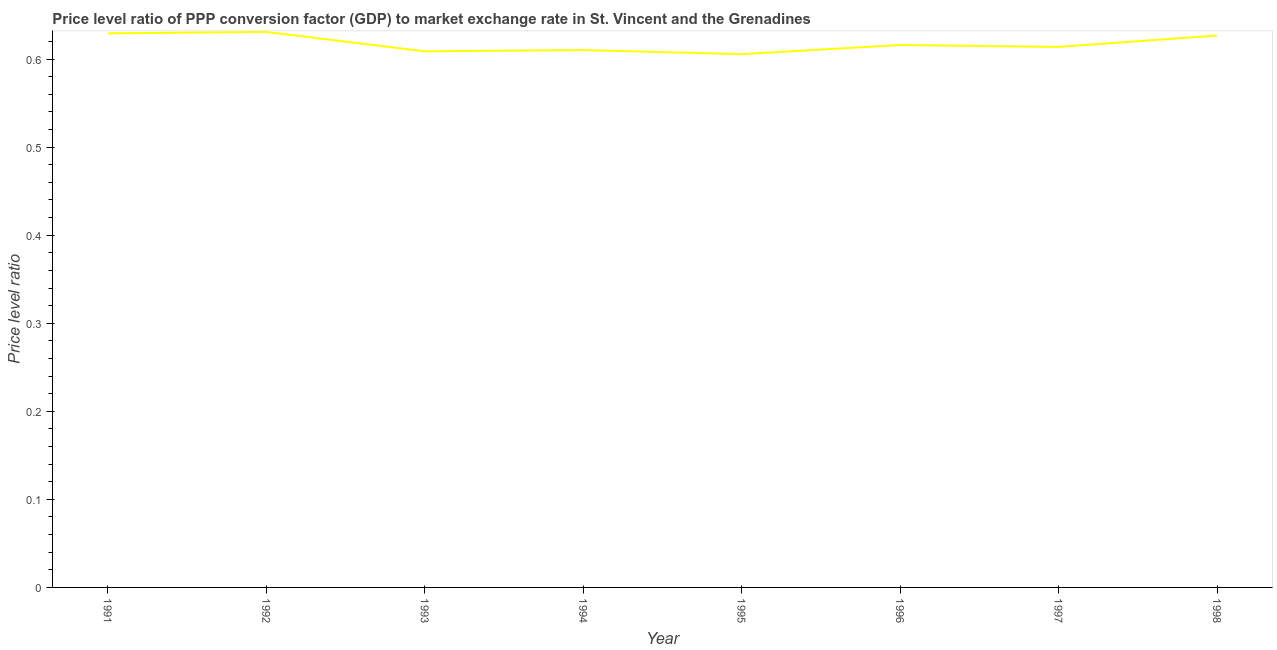What is the price level ratio in 1994?
Offer a very short reply. 0.61. Across all years, what is the maximum price level ratio?
Offer a very short reply. 0.63. Across all years, what is the minimum price level ratio?
Offer a terse response. 0.61. In which year was the price level ratio maximum?
Provide a succinct answer. 1992. In which year was the price level ratio minimum?
Your answer should be compact. 1995. What is the sum of the price level ratio?
Your response must be concise. 4.94. What is the difference between the price level ratio in 1994 and 1998?
Offer a very short reply. -0.02. What is the average price level ratio per year?
Ensure brevity in your answer.  0.62. What is the median price level ratio?
Ensure brevity in your answer.  0.61. In how many years, is the price level ratio greater than 0.22 ?
Make the answer very short. 8. Do a majority of the years between 1997 and 1992 (inclusive) have price level ratio greater than 0.30000000000000004 ?
Provide a succinct answer. Yes. What is the ratio of the price level ratio in 1993 to that in 1998?
Your response must be concise. 0.97. What is the difference between the highest and the second highest price level ratio?
Keep it short and to the point. 0. Is the sum of the price level ratio in 1995 and 1996 greater than the maximum price level ratio across all years?
Your answer should be very brief. Yes. What is the difference between the highest and the lowest price level ratio?
Ensure brevity in your answer.  0.03. In how many years, is the price level ratio greater than the average price level ratio taken over all years?
Your answer should be compact. 3. How many years are there in the graph?
Make the answer very short. 8. What is the difference between two consecutive major ticks on the Y-axis?
Give a very brief answer. 0.1. Does the graph contain any zero values?
Ensure brevity in your answer.  No. Does the graph contain grids?
Provide a short and direct response. No. What is the title of the graph?
Keep it short and to the point. Price level ratio of PPP conversion factor (GDP) to market exchange rate in St. Vincent and the Grenadines. What is the label or title of the Y-axis?
Ensure brevity in your answer.  Price level ratio. What is the Price level ratio in 1991?
Provide a short and direct response. 0.63. What is the Price level ratio of 1992?
Provide a succinct answer. 0.63. What is the Price level ratio of 1993?
Your answer should be compact. 0.61. What is the Price level ratio in 1994?
Keep it short and to the point. 0.61. What is the Price level ratio in 1995?
Your response must be concise. 0.61. What is the Price level ratio in 1996?
Offer a terse response. 0.62. What is the Price level ratio of 1997?
Offer a very short reply. 0.61. What is the Price level ratio in 1998?
Provide a succinct answer. 0.63. What is the difference between the Price level ratio in 1991 and 1992?
Keep it short and to the point. -0. What is the difference between the Price level ratio in 1991 and 1993?
Your response must be concise. 0.02. What is the difference between the Price level ratio in 1991 and 1994?
Give a very brief answer. 0.02. What is the difference between the Price level ratio in 1991 and 1995?
Make the answer very short. 0.02. What is the difference between the Price level ratio in 1991 and 1996?
Keep it short and to the point. 0.01. What is the difference between the Price level ratio in 1991 and 1997?
Make the answer very short. 0.02. What is the difference between the Price level ratio in 1991 and 1998?
Keep it short and to the point. 0. What is the difference between the Price level ratio in 1992 and 1993?
Your answer should be compact. 0.02. What is the difference between the Price level ratio in 1992 and 1994?
Give a very brief answer. 0.02. What is the difference between the Price level ratio in 1992 and 1995?
Provide a short and direct response. 0.03. What is the difference between the Price level ratio in 1992 and 1996?
Your answer should be compact. 0.01. What is the difference between the Price level ratio in 1992 and 1997?
Your response must be concise. 0.02. What is the difference between the Price level ratio in 1992 and 1998?
Provide a short and direct response. 0. What is the difference between the Price level ratio in 1993 and 1994?
Make the answer very short. -0. What is the difference between the Price level ratio in 1993 and 1995?
Ensure brevity in your answer.  0. What is the difference between the Price level ratio in 1993 and 1996?
Your response must be concise. -0.01. What is the difference between the Price level ratio in 1993 and 1997?
Keep it short and to the point. -0.01. What is the difference between the Price level ratio in 1993 and 1998?
Ensure brevity in your answer.  -0.02. What is the difference between the Price level ratio in 1994 and 1995?
Your response must be concise. 0. What is the difference between the Price level ratio in 1994 and 1996?
Your response must be concise. -0.01. What is the difference between the Price level ratio in 1994 and 1997?
Give a very brief answer. -0. What is the difference between the Price level ratio in 1994 and 1998?
Keep it short and to the point. -0.02. What is the difference between the Price level ratio in 1995 and 1996?
Offer a very short reply. -0.01. What is the difference between the Price level ratio in 1995 and 1997?
Make the answer very short. -0.01. What is the difference between the Price level ratio in 1995 and 1998?
Your answer should be very brief. -0.02. What is the difference between the Price level ratio in 1996 and 1997?
Provide a succinct answer. 0. What is the difference between the Price level ratio in 1996 and 1998?
Provide a short and direct response. -0.01. What is the difference between the Price level ratio in 1997 and 1998?
Give a very brief answer. -0.01. What is the ratio of the Price level ratio in 1991 to that in 1993?
Make the answer very short. 1.03. What is the ratio of the Price level ratio in 1991 to that in 1994?
Offer a terse response. 1.03. What is the ratio of the Price level ratio in 1991 to that in 1995?
Your answer should be very brief. 1.04. What is the ratio of the Price level ratio in 1991 to that in 1998?
Provide a short and direct response. 1. What is the ratio of the Price level ratio in 1992 to that in 1993?
Provide a succinct answer. 1.04. What is the ratio of the Price level ratio in 1992 to that in 1994?
Keep it short and to the point. 1.03. What is the ratio of the Price level ratio in 1992 to that in 1995?
Your response must be concise. 1.04. What is the ratio of the Price level ratio in 1992 to that in 1997?
Make the answer very short. 1.03. What is the ratio of the Price level ratio in 1992 to that in 1998?
Offer a terse response. 1.01. What is the ratio of the Price level ratio in 1993 to that in 1994?
Your answer should be compact. 1. What is the ratio of the Price level ratio in 1993 to that in 1998?
Ensure brevity in your answer.  0.97. What is the ratio of the Price level ratio in 1994 to that in 1995?
Your answer should be very brief. 1.01. What is the ratio of the Price level ratio in 1994 to that in 1997?
Provide a short and direct response. 0.99. What is the ratio of the Price level ratio in 1994 to that in 1998?
Your answer should be very brief. 0.97. What is the ratio of the Price level ratio in 1995 to that in 1996?
Offer a terse response. 0.98. What is the ratio of the Price level ratio in 1996 to that in 1997?
Give a very brief answer. 1. What is the ratio of the Price level ratio in 1996 to that in 1998?
Your answer should be compact. 0.98. What is the ratio of the Price level ratio in 1997 to that in 1998?
Make the answer very short. 0.98. 